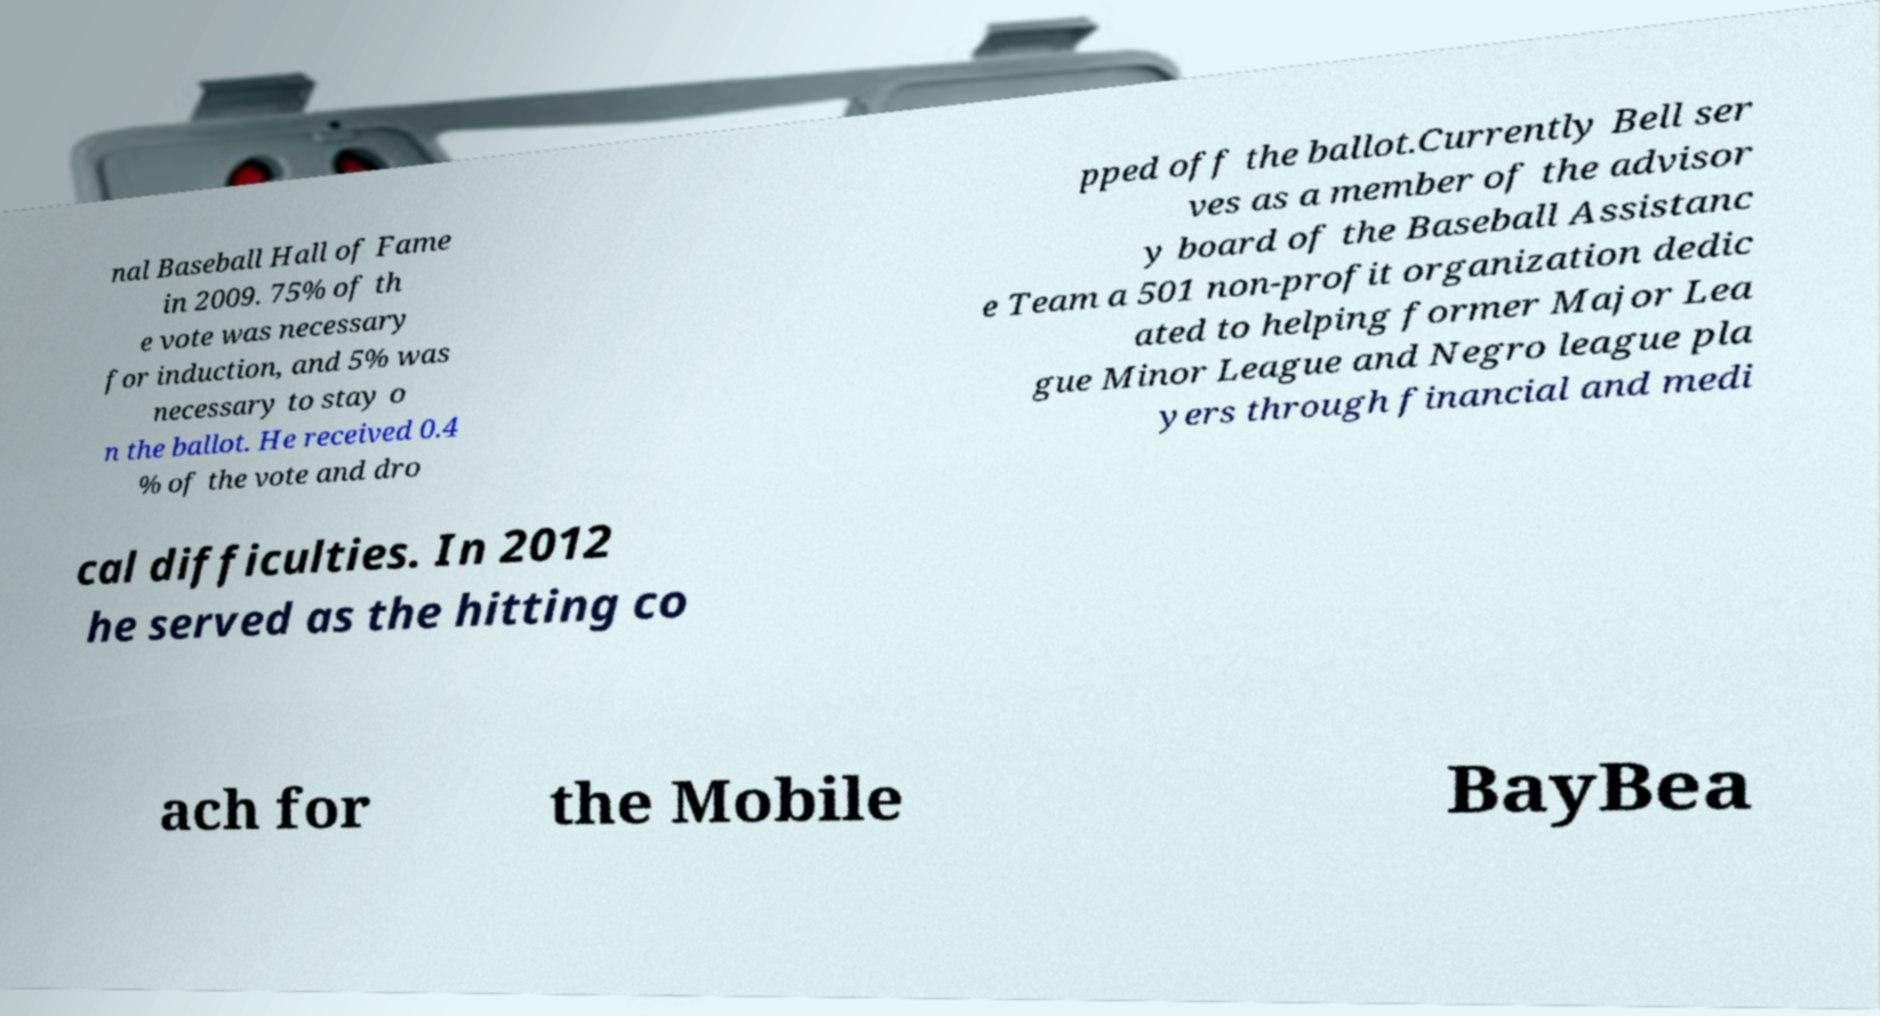There's text embedded in this image that I need extracted. Can you transcribe it verbatim? nal Baseball Hall of Fame in 2009. 75% of th e vote was necessary for induction, and 5% was necessary to stay o n the ballot. He received 0.4 % of the vote and dro pped off the ballot.Currently Bell ser ves as a member of the advisor y board of the Baseball Assistanc e Team a 501 non-profit organization dedic ated to helping former Major Lea gue Minor League and Negro league pla yers through financial and medi cal difficulties. In 2012 he served as the hitting co ach for the Mobile BayBea 